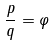<formula> <loc_0><loc_0><loc_500><loc_500>\frac { p } { q } = \varphi</formula> 